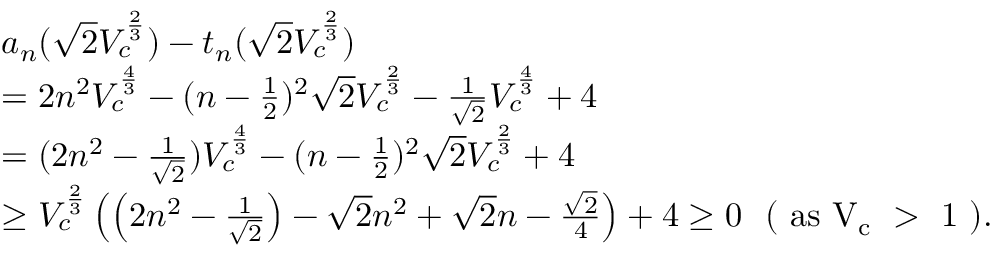<formula> <loc_0><loc_0><loc_500><loc_500>\begin{array} { r l } & { a _ { n } ( \sqrt { 2 } V _ { c } ^ { \frac { 2 } { 3 } } ) - t _ { n } ( \sqrt { 2 } V _ { c } ^ { \frac { 2 } { 3 } } ) } \\ & { = 2 n ^ { 2 } V _ { c } ^ { \frac { 4 } { 3 } } - ( n - \frac { 1 } { 2 } ) ^ { 2 } \sqrt { 2 } V _ { c } ^ { \frac { 2 } { 3 } } - \frac { 1 } { \sqrt { 2 } } V _ { c } ^ { \frac { 4 } { 3 } } + 4 } \\ & { = ( 2 n ^ { 2 } - \frac { 1 } { \sqrt { 2 } } ) V _ { c } ^ { \frac { 4 } { 3 } } - ( n - \frac { 1 } { 2 } ) ^ { 2 } \sqrt { 2 } V _ { c } ^ { \frac { 2 } { 3 } } + 4 } \\ & { \geq V _ { c } ^ { \frac { 2 } { 3 } } \left ( \left ( 2 n ^ { 2 } - \frac { 1 } { \sqrt { 2 } } \right ) - \sqrt { 2 } n ^ { 2 } + \sqrt { 2 } n - \frac { \sqrt { 2 } } { 4 } \right ) + 4 \geq 0 ( a s V _ { c } > 1 ) . } \end{array}</formula> 